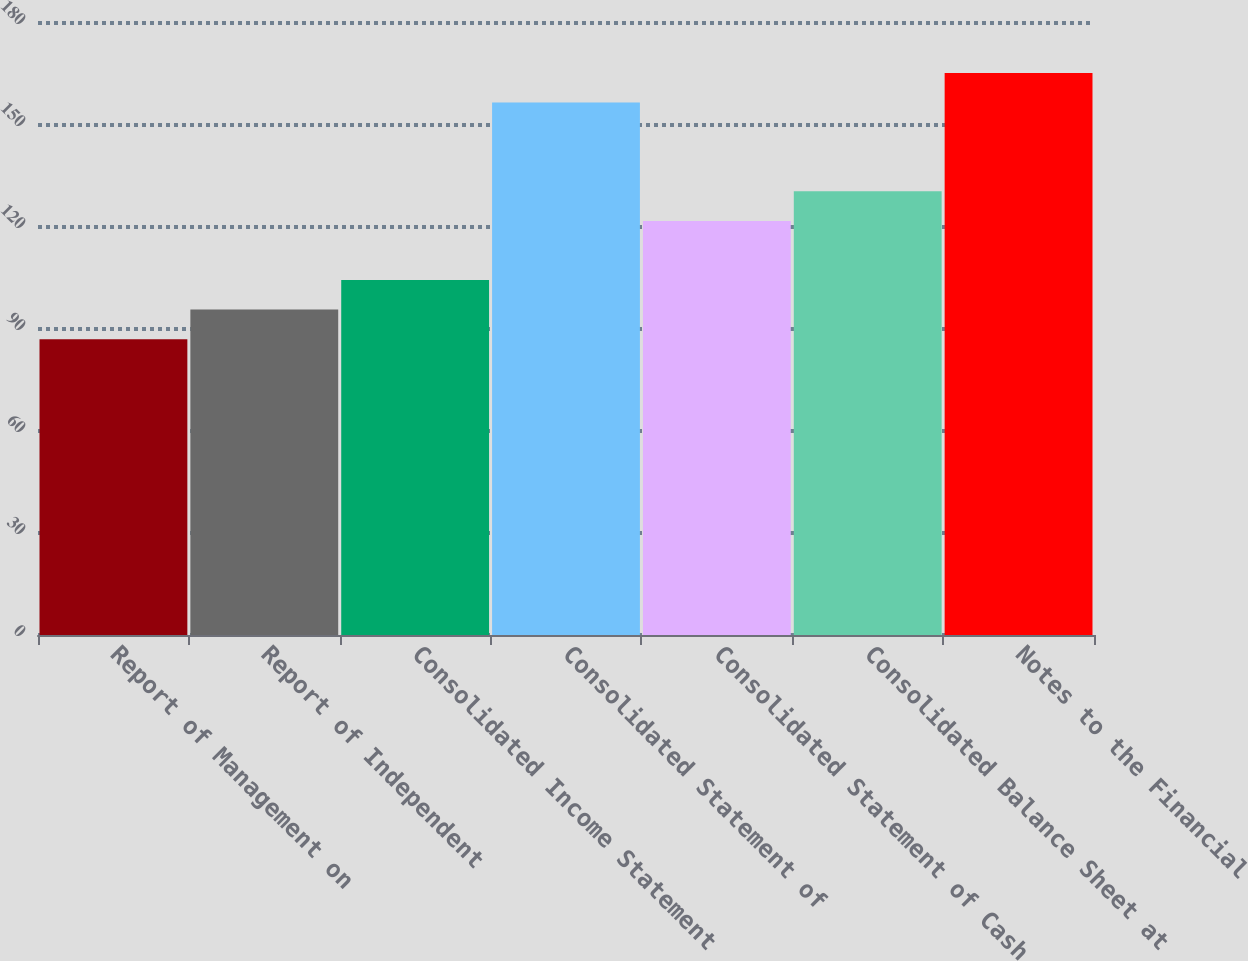Convert chart. <chart><loc_0><loc_0><loc_500><loc_500><bar_chart><fcel>Report of Management on<fcel>Report of Independent<fcel>Consolidated Income Statement<fcel>Consolidated Statement of<fcel>Consolidated Statement of Cash<fcel>Consolidated Balance Sheet at<fcel>Notes to the Financial<nl><fcel>87<fcel>95.7<fcel>104.4<fcel>156.6<fcel>121.8<fcel>130.5<fcel>165.3<nl></chart> 